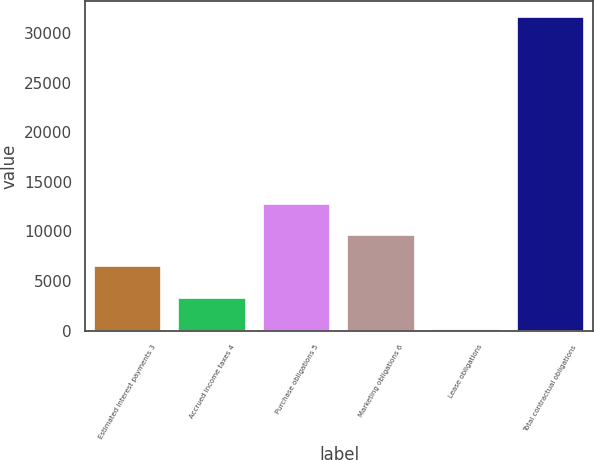<chart> <loc_0><loc_0><loc_500><loc_500><bar_chart><fcel>Estimated interest payments 3<fcel>Accrued income taxes 4<fcel>Purchase obligations 5<fcel>Marketing obligations 6<fcel>Lease obligations<fcel>Total contractual obligations<nl><fcel>6467.2<fcel>3324.1<fcel>12753.4<fcel>9610.3<fcel>181<fcel>31612<nl></chart> 